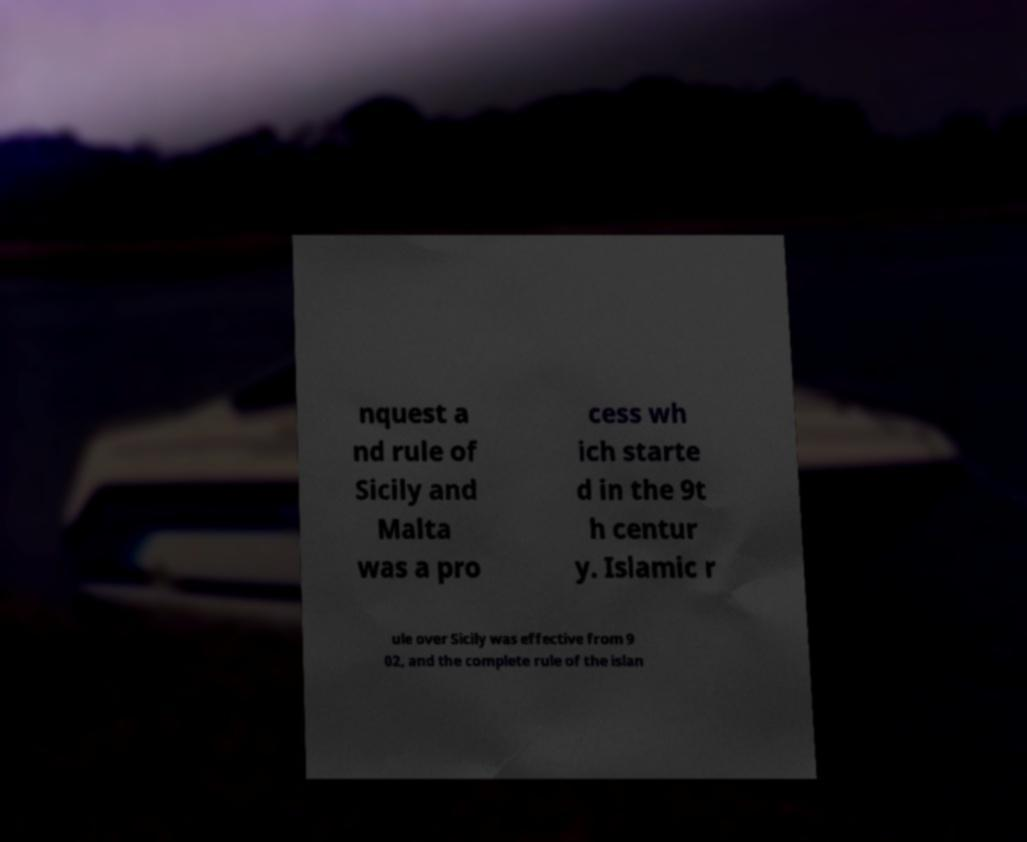For documentation purposes, I need the text within this image transcribed. Could you provide that? nquest a nd rule of Sicily and Malta was a pro cess wh ich starte d in the 9t h centur y. Islamic r ule over Sicily was effective from 9 02, and the complete rule of the islan 